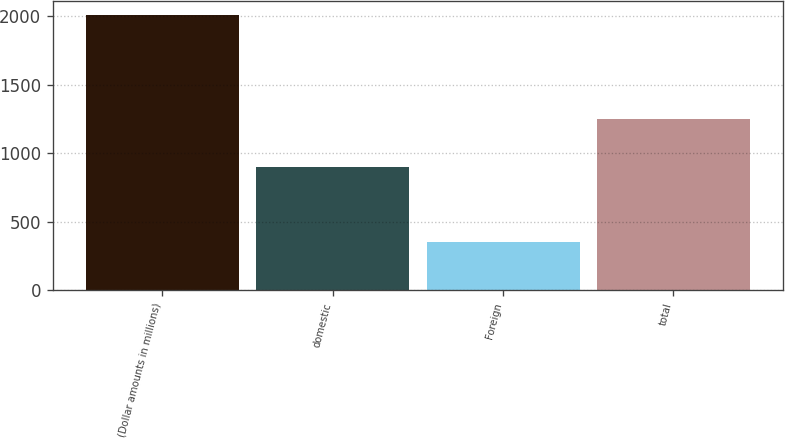Convert chart to OTSL. <chart><loc_0><loc_0><loc_500><loc_500><bar_chart><fcel>(Dollar amounts in millions)<fcel>domestic<fcel>Foreign<fcel>total<nl><fcel>2009<fcel>899<fcel>351<fcel>1250<nl></chart> 